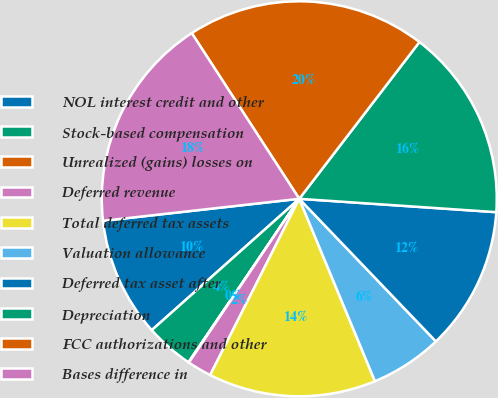Convert chart. <chart><loc_0><loc_0><loc_500><loc_500><pie_chart><fcel>NOL interest credit and other<fcel>Stock-based compensation<fcel>Unrealized (gains) losses on<fcel>Deferred revenue<fcel>Total deferred tax assets<fcel>Valuation allowance<fcel>Deferred tax asset after<fcel>Depreciation<fcel>FCC authorizations and other<fcel>Bases difference in<nl><fcel>9.8%<fcel>3.94%<fcel>0.04%<fcel>1.99%<fcel>13.71%<fcel>5.9%<fcel>11.76%<fcel>15.67%<fcel>19.57%<fcel>17.62%<nl></chart> 